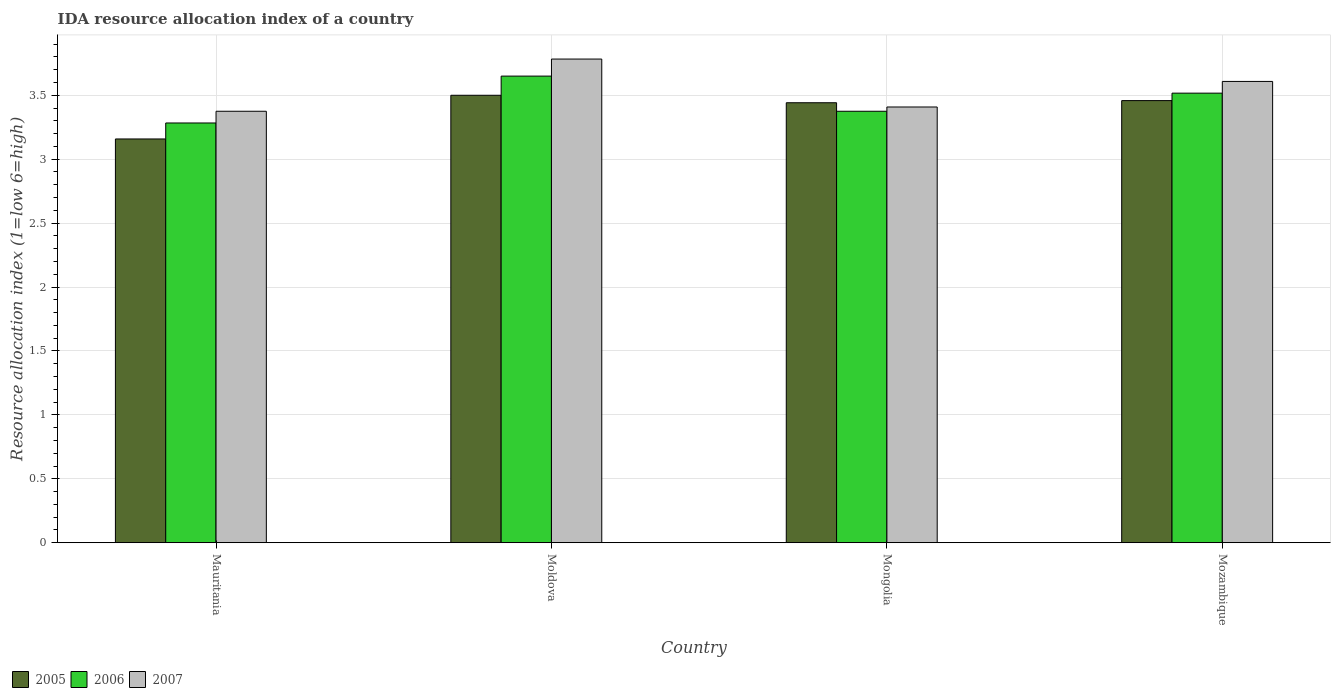Are the number of bars per tick equal to the number of legend labels?
Offer a terse response. Yes. Are the number of bars on each tick of the X-axis equal?
Your response must be concise. Yes. How many bars are there on the 2nd tick from the left?
Ensure brevity in your answer.  3. How many bars are there on the 4th tick from the right?
Make the answer very short. 3. What is the label of the 1st group of bars from the left?
Your response must be concise. Mauritania. In how many cases, is the number of bars for a given country not equal to the number of legend labels?
Offer a terse response. 0. What is the IDA resource allocation index in 2006 in Moldova?
Your response must be concise. 3.65. Across all countries, what is the maximum IDA resource allocation index in 2007?
Ensure brevity in your answer.  3.78. Across all countries, what is the minimum IDA resource allocation index in 2005?
Your answer should be compact. 3.16. In which country was the IDA resource allocation index in 2007 maximum?
Your response must be concise. Moldova. In which country was the IDA resource allocation index in 2007 minimum?
Ensure brevity in your answer.  Mauritania. What is the total IDA resource allocation index in 2007 in the graph?
Your response must be concise. 14.17. What is the difference between the IDA resource allocation index in 2007 in Mongolia and that in Mozambique?
Offer a very short reply. -0.2. What is the difference between the IDA resource allocation index in 2005 in Mongolia and the IDA resource allocation index in 2006 in Mozambique?
Ensure brevity in your answer.  -0.08. What is the average IDA resource allocation index in 2006 per country?
Give a very brief answer. 3.46. What is the difference between the IDA resource allocation index of/in 2005 and IDA resource allocation index of/in 2007 in Mozambique?
Offer a terse response. -0.15. In how many countries, is the IDA resource allocation index in 2006 greater than 2.4?
Your response must be concise. 4. What is the ratio of the IDA resource allocation index in 2006 in Moldova to that in Mozambique?
Ensure brevity in your answer.  1.04. Is the IDA resource allocation index in 2007 in Mauritania less than that in Mongolia?
Make the answer very short. Yes. Is the difference between the IDA resource allocation index in 2005 in Mauritania and Mongolia greater than the difference between the IDA resource allocation index in 2007 in Mauritania and Mongolia?
Your response must be concise. No. What is the difference between the highest and the second highest IDA resource allocation index in 2006?
Offer a terse response. 0.14. What is the difference between the highest and the lowest IDA resource allocation index in 2007?
Your response must be concise. 0.41. In how many countries, is the IDA resource allocation index in 2006 greater than the average IDA resource allocation index in 2006 taken over all countries?
Give a very brief answer. 2. Is the sum of the IDA resource allocation index in 2005 in Moldova and Mongolia greater than the maximum IDA resource allocation index in 2006 across all countries?
Provide a succinct answer. Yes. What does the 1st bar from the left in Mozambique represents?
Offer a very short reply. 2005. What does the 1st bar from the right in Mongolia represents?
Keep it short and to the point. 2007. Is it the case that in every country, the sum of the IDA resource allocation index in 2007 and IDA resource allocation index in 2005 is greater than the IDA resource allocation index in 2006?
Keep it short and to the point. Yes. Does the graph contain any zero values?
Provide a short and direct response. No. Does the graph contain grids?
Offer a very short reply. Yes. Where does the legend appear in the graph?
Your answer should be very brief. Bottom left. What is the title of the graph?
Offer a very short reply. IDA resource allocation index of a country. What is the label or title of the X-axis?
Your answer should be very brief. Country. What is the label or title of the Y-axis?
Your answer should be very brief. Resource allocation index (1=low 6=high). What is the Resource allocation index (1=low 6=high) of 2005 in Mauritania?
Your response must be concise. 3.16. What is the Resource allocation index (1=low 6=high) of 2006 in Mauritania?
Your answer should be very brief. 3.28. What is the Resource allocation index (1=low 6=high) in 2007 in Mauritania?
Offer a very short reply. 3.38. What is the Resource allocation index (1=low 6=high) of 2006 in Moldova?
Your answer should be compact. 3.65. What is the Resource allocation index (1=low 6=high) in 2007 in Moldova?
Provide a succinct answer. 3.78. What is the Resource allocation index (1=low 6=high) of 2005 in Mongolia?
Provide a short and direct response. 3.44. What is the Resource allocation index (1=low 6=high) in 2006 in Mongolia?
Give a very brief answer. 3.38. What is the Resource allocation index (1=low 6=high) of 2007 in Mongolia?
Provide a succinct answer. 3.41. What is the Resource allocation index (1=low 6=high) of 2005 in Mozambique?
Offer a very short reply. 3.46. What is the Resource allocation index (1=low 6=high) of 2006 in Mozambique?
Make the answer very short. 3.52. What is the Resource allocation index (1=low 6=high) in 2007 in Mozambique?
Give a very brief answer. 3.61. Across all countries, what is the maximum Resource allocation index (1=low 6=high) in 2005?
Make the answer very short. 3.5. Across all countries, what is the maximum Resource allocation index (1=low 6=high) in 2006?
Offer a very short reply. 3.65. Across all countries, what is the maximum Resource allocation index (1=low 6=high) in 2007?
Make the answer very short. 3.78. Across all countries, what is the minimum Resource allocation index (1=low 6=high) in 2005?
Give a very brief answer. 3.16. Across all countries, what is the minimum Resource allocation index (1=low 6=high) in 2006?
Your answer should be compact. 3.28. Across all countries, what is the minimum Resource allocation index (1=low 6=high) in 2007?
Provide a succinct answer. 3.38. What is the total Resource allocation index (1=low 6=high) in 2005 in the graph?
Keep it short and to the point. 13.56. What is the total Resource allocation index (1=low 6=high) in 2006 in the graph?
Offer a very short reply. 13.82. What is the total Resource allocation index (1=low 6=high) of 2007 in the graph?
Offer a terse response. 14.18. What is the difference between the Resource allocation index (1=low 6=high) in 2005 in Mauritania and that in Moldova?
Provide a short and direct response. -0.34. What is the difference between the Resource allocation index (1=low 6=high) in 2006 in Mauritania and that in Moldova?
Ensure brevity in your answer.  -0.37. What is the difference between the Resource allocation index (1=low 6=high) of 2007 in Mauritania and that in Moldova?
Make the answer very short. -0.41. What is the difference between the Resource allocation index (1=low 6=high) in 2005 in Mauritania and that in Mongolia?
Make the answer very short. -0.28. What is the difference between the Resource allocation index (1=low 6=high) of 2006 in Mauritania and that in Mongolia?
Your response must be concise. -0.09. What is the difference between the Resource allocation index (1=low 6=high) in 2007 in Mauritania and that in Mongolia?
Offer a terse response. -0.03. What is the difference between the Resource allocation index (1=low 6=high) of 2005 in Mauritania and that in Mozambique?
Ensure brevity in your answer.  -0.3. What is the difference between the Resource allocation index (1=low 6=high) in 2006 in Mauritania and that in Mozambique?
Provide a succinct answer. -0.23. What is the difference between the Resource allocation index (1=low 6=high) in 2007 in Mauritania and that in Mozambique?
Your response must be concise. -0.23. What is the difference between the Resource allocation index (1=low 6=high) of 2005 in Moldova and that in Mongolia?
Provide a succinct answer. 0.06. What is the difference between the Resource allocation index (1=low 6=high) of 2006 in Moldova and that in Mongolia?
Give a very brief answer. 0.28. What is the difference between the Resource allocation index (1=low 6=high) of 2007 in Moldova and that in Mongolia?
Your answer should be compact. 0.38. What is the difference between the Resource allocation index (1=low 6=high) of 2005 in Moldova and that in Mozambique?
Provide a succinct answer. 0.04. What is the difference between the Resource allocation index (1=low 6=high) of 2006 in Moldova and that in Mozambique?
Keep it short and to the point. 0.13. What is the difference between the Resource allocation index (1=low 6=high) of 2007 in Moldova and that in Mozambique?
Give a very brief answer. 0.17. What is the difference between the Resource allocation index (1=low 6=high) of 2005 in Mongolia and that in Mozambique?
Offer a terse response. -0.02. What is the difference between the Resource allocation index (1=low 6=high) of 2006 in Mongolia and that in Mozambique?
Your answer should be very brief. -0.14. What is the difference between the Resource allocation index (1=low 6=high) in 2005 in Mauritania and the Resource allocation index (1=low 6=high) in 2006 in Moldova?
Your answer should be very brief. -0.49. What is the difference between the Resource allocation index (1=low 6=high) in 2005 in Mauritania and the Resource allocation index (1=low 6=high) in 2007 in Moldova?
Your answer should be compact. -0.62. What is the difference between the Resource allocation index (1=low 6=high) of 2006 in Mauritania and the Resource allocation index (1=low 6=high) of 2007 in Moldova?
Give a very brief answer. -0.5. What is the difference between the Resource allocation index (1=low 6=high) of 2005 in Mauritania and the Resource allocation index (1=low 6=high) of 2006 in Mongolia?
Make the answer very short. -0.22. What is the difference between the Resource allocation index (1=low 6=high) of 2006 in Mauritania and the Resource allocation index (1=low 6=high) of 2007 in Mongolia?
Offer a very short reply. -0.12. What is the difference between the Resource allocation index (1=low 6=high) in 2005 in Mauritania and the Resource allocation index (1=low 6=high) in 2006 in Mozambique?
Your response must be concise. -0.36. What is the difference between the Resource allocation index (1=low 6=high) in 2005 in Mauritania and the Resource allocation index (1=low 6=high) in 2007 in Mozambique?
Offer a very short reply. -0.45. What is the difference between the Resource allocation index (1=low 6=high) of 2006 in Mauritania and the Resource allocation index (1=low 6=high) of 2007 in Mozambique?
Your answer should be very brief. -0.33. What is the difference between the Resource allocation index (1=low 6=high) in 2005 in Moldova and the Resource allocation index (1=low 6=high) in 2007 in Mongolia?
Give a very brief answer. 0.09. What is the difference between the Resource allocation index (1=low 6=high) of 2006 in Moldova and the Resource allocation index (1=low 6=high) of 2007 in Mongolia?
Keep it short and to the point. 0.24. What is the difference between the Resource allocation index (1=low 6=high) of 2005 in Moldova and the Resource allocation index (1=low 6=high) of 2006 in Mozambique?
Offer a terse response. -0.02. What is the difference between the Resource allocation index (1=low 6=high) of 2005 in Moldova and the Resource allocation index (1=low 6=high) of 2007 in Mozambique?
Provide a short and direct response. -0.11. What is the difference between the Resource allocation index (1=low 6=high) of 2006 in Moldova and the Resource allocation index (1=low 6=high) of 2007 in Mozambique?
Provide a short and direct response. 0.04. What is the difference between the Resource allocation index (1=low 6=high) of 2005 in Mongolia and the Resource allocation index (1=low 6=high) of 2006 in Mozambique?
Make the answer very short. -0.07. What is the difference between the Resource allocation index (1=low 6=high) of 2005 in Mongolia and the Resource allocation index (1=low 6=high) of 2007 in Mozambique?
Offer a terse response. -0.17. What is the difference between the Resource allocation index (1=low 6=high) in 2006 in Mongolia and the Resource allocation index (1=low 6=high) in 2007 in Mozambique?
Provide a short and direct response. -0.23. What is the average Resource allocation index (1=low 6=high) in 2005 per country?
Ensure brevity in your answer.  3.39. What is the average Resource allocation index (1=low 6=high) in 2006 per country?
Offer a terse response. 3.46. What is the average Resource allocation index (1=low 6=high) in 2007 per country?
Keep it short and to the point. 3.54. What is the difference between the Resource allocation index (1=low 6=high) of 2005 and Resource allocation index (1=low 6=high) of 2006 in Mauritania?
Keep it short and to the point. -0.12. What is the difference between the Resource allocation index (1=low 6=high) of 2005 and Resource allocation index (1=low 6=high) of 2007 in Mauritania?
Provide a short and direct response. -0.22. What is the difference between the Resource allocation index (1=low 6=high) of 2006 and Resource allocation index (1=low 6=high) of 2007 in Mauritania?
Your answer should be very brief. -0.09. What is the difference between the Resource allocation index (1=low 6=high) of 2005 and Resource allocation index (1=low 6=high) of 2006 in Moldova?
Provide a short and direct response. -0.15. What is the difference between the Resource allocation index (1=low 6=high) in 2005 and Resource allocation index (1=low 6=high) in 2007 in Moldova?
Offer a very short reply. -0.28. What is the difference between the Resource allocation index (1=low 6=high) of 2006 and Resource allocation index (1=low 6=high) of 2007 in Moldova?
Your answer should be very brief. -0.13. What is the difference between the Resource allocation index (1=low 6=high) of 2005 and Resource allocation index (1=low 6=high) of 2006 in Mongolia?
Your answer should be very brief. 0.07. What is the difference between the Resource allocation index (1=low 6=high) in 2006 and Resource allocation index (1=low 6=high) in 2007 in Mongolia?
Your answer should be compact. -0.03. What is the difference between the Resource allocation index (1=low 6=high) of 2005 and Resource allocation index (1=low 6=high) of 2006 in Mozambique?
Make the answer very short. -0.06. What is the difference between the Resource allocation index (1=low 6=high) of 2005 and Resource allocation index (1=low 6=high) of 2007 in Mozambique?
Provide a succinct answer. -0.15. What is the difference between the Resource allocation index (1=low 6=high) in 2006 and Resource allocation index (1=low 6=high) in 2007 in Mozambique?
Your answer should be very brief. -0.09. What is the ratio of the Resource allocation index (1=low 6=high) in 2005 in Mauritania to that in Moldova?
Provide a succinct answer. 0.9. What is the ratio of the Resource allocation index (1=low 6=high) of 2006 in Mauritania to that in Moldova?
Give a very brief answer. 0.9. What is the ratio of the Resource allocation index (1=low 6=high) in 2007 in Mauritania to that in Moldova?
Provide a short and direct response. 0.89. What is the ratio of the Resource allocation index (1=low 6=high) in 2005 in Mauritania to that in Mongolia?
Your answer should be very brief. 0.92. What is the ratio of the Resource allocation index (1=low 6=high) of 2006 in Mauritania to that in Mongolia?
Offer a very short reply. 0.97. What is the ratio of the Resource allocation index (1=low 6=high) of 2007 in Mauritania to that in Mongolia?
Give a very brief answer. 0.99. What is the ratio of the Resource allocation index (1=low 6=high) in 2005 in Mauritania to that in Mozambique?
Your response must be concise. 0.91. What is the ratio of the Resource allocation index (1=low 6=high) of 2006 in Mauritania to that in Mozambique?
Provide a short and direct response. 0.93. What is the ratio of the Resource allocation index (1=low 6=high) in 2007 in Mauritania to that in Mozambique?
Make the answer very short. 0.94. What is the ratio of the Resource allocation index (1=low 6=high) in 2005 in Moldova to that in Mongolia?
Ensure brevity in your answer.  1.02. What is the ratio of the Resource allocation index (1=low 6=high) of 2006 in Moldova to that in Mongolia?
Offer a very short reply. 1.08. What is the ratio of the Resource allocation index (1=low 6=high) of 2007 in Moldova to that in Mongolia?
Offer a terse response. 1.11. What is the ratio of the Resource allocation index (1=low 6=high) of 2005 in Moldova to that in Mozambique?
Offer a terse response. 1.01. What is the ratio of the Resource allocation index (1=low 6=high) of 2006 in Moldova to that in Mozambique?
Keep it short and to the point. 1.04. What is the ratio of the Resource allocation index (1=low 6=high) in 2007 in Moldova to that in Mozambique?
Provide a short and direct response. 1.05. What is the ratio of the Resource allocation index (1=low 6=high) in 2005 in Mongolia to that in Mozambique?
Make the answer very short. 1. What is the ratio of the Resource allocation index (1=low 6=high) in 2006 in Mongolia to that in Mozambique?
Provide a succinct answer. 0.96. What is the ratio of the Resource allocation index (1=low 6=high) in 2007 in Mongolia to that in Mozambique?
Provide a short and direct response. 0.94. What is the difference between the highest and the second highest Resource allocation index (1=low 6=high) of 2005?
Keep it short and to the point. 0.04. What is the difference between the highest and the second highest Resource allocation index (1=low 6=high) in 2006?
Provide a short and direct response. 0.13. What is the difference between the highest and the second highest Resource allocation index (1=low 6=high) in 2007?
Provide a succinct answer. 0.17. What is the difference between the highest and the lowest Resource allocation index (1=low 6=high) of 2005?
Offer a very short reply. 0.34. What is the difference between the highest and the lowest Resource allocation index (1=low 6=high) in 2006?
Provide a short and direct response. 0.37. What is the difference between the highest and the lowest Resource allocation index (1=low 6=high) in 2007?
Your answer should be very brief. 0.41. 